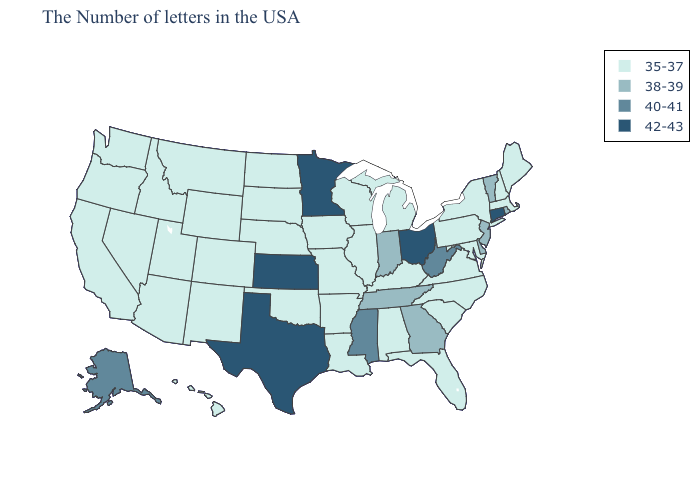Name the states that have a value in the range 38-39?
Be succinct. Rhode Island, Vermont, New Jersey, Delaware, Georgia, Indiana, Tennessee. What is the lowest value in the USA?
Quick response, please. 35-37. What is the lowest value in states that border Missouri?
Short answer required. 35-37. Name the states that have a value in the range 38-39?
Quick response, please. Rhode Island, Vermont, New Jersey, Delaware, Georgia, Indiana, Tennessee. What is the lowest value in the Northeast?
Quick response, please. 35-37. Which states have the lowest value in the USA?
Quick response, please. Maine, Massachusetts, New Hampshire, New York, Maryland, Pennsylvania, Virginia, North Carolina, South Carolina, Florida, Michigan, Kentucky, Alabama, Wisconsin, Illinois, Louisiana, Missouri, Arkansas, Iowa, Nebraska, Oklahoma, South Dakota, North Dakota, Wyoming, Colorado, New Mexico, Utah, Montana, Arizona, Idaho, Nevada, California, Washington, Oregon, Hawaii. What is the value of Montana?
Answer briefly. 35-37. Name the states that have a value in the range 35-37?
Quick response, please. Maine, Massachusetts, New Hampshire, New York, Maryland, Pennsylvania, Virginia, North Carolina, South Carolina, Florida, Michigan, Kentucky, Alabama, Wisconsin, Illinois, Louisiana, Missouri, Arkansas, Iowa, Nebraska, Oklahoma, South Dakota, North Dakota, Wyoming, Colorado, New Mexico, Utah, Montana, Arizona, Idaho, Nevada, California, Washington, Oregon, Hawaii. Name the states that have a value in the range 35-37?
Give a very brief answer. Maine, Massachusetts, New Hampshire, New York, Maryland, Pennsylvania, Virginia, North Carolina, South Carolina, Florida, Michigan, Kentucky, Alabama, Wisconsin, Illinois, Louisiana, Missouri, Arkansas, Iowa, Nebraska, Oklahoma, South Dakota, North Dakota, Wyoming, Colorado, New Mexico, Utah, Montana, Arizona, Idaho, Nevada, California, Washington, Oregon, Hawaii. Among the states that border Rhode Island , which have the highest value?
Be succinct. Connecticut. What is the lowest value in the MidWest?
Answer briefly. 35-37. Does Alabama have a lower value than Connecticut?
Give a very brief answer. Yes. How many symbols are there in the legend?
Answer briefly. 4. What is the value of Kentucky?
Quick response, please. 35-37. 